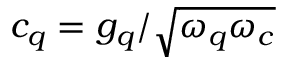Convert formula to latex. <formula><loc_0><loc_0><loc_500><loc_500>c _ { q } = g _ { q } / \sqrt { \omega _ { q } \omega _ { c } }</formula> 